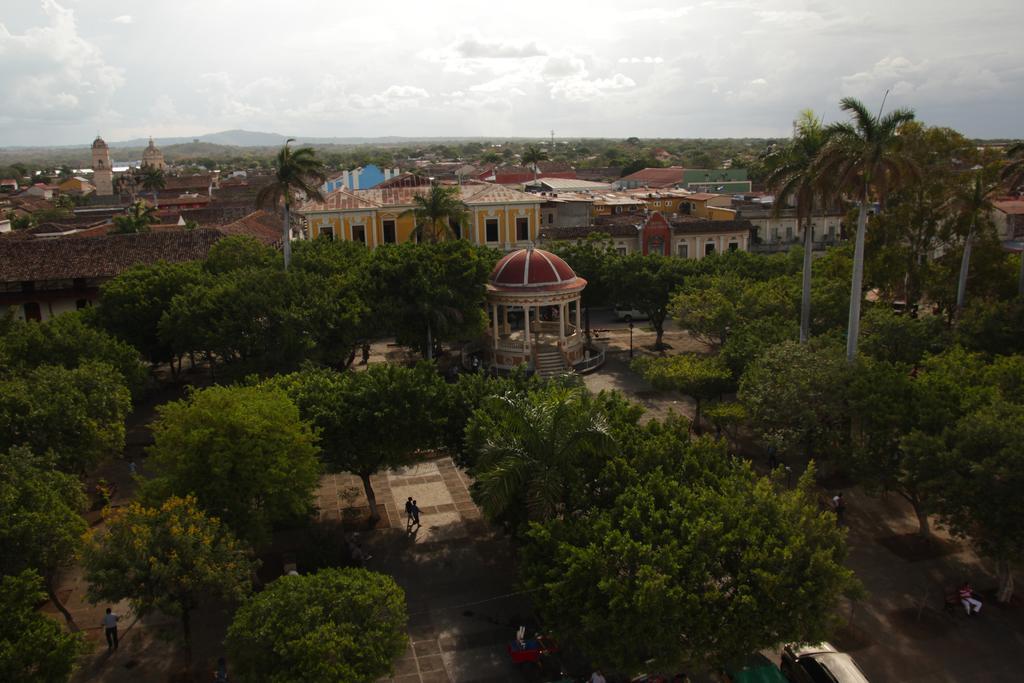Could you give a brief overview of what you see in this image? In this picture we can see some trees, walkway, persons walking along the walkway, in the background of the picture there are some houses and mountains and top of the picture there is clear sky. 